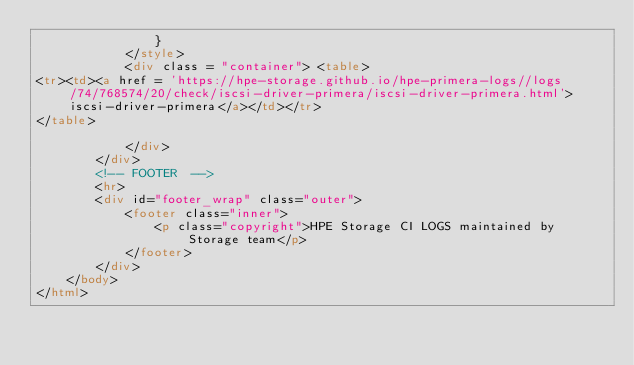<code> <loc_0><loc_0><loc_500><loc_500><_HTML_>                }
            </style>
            <div class = "container"> <table>
<tr><td><a href = 'https://hpe-storage.github.io/hpe-primera-logs//logs/74/768574/20/check/iscsi-driver-primera/iscsi-driver-primera.html'>iscsi-driver-primera</a></td></tr>
</table>

            </div>
        </div>
        <!-- FOOTER  -->
        <hr>
        <div id="footer_wrap" class="outer">
            <footer class="inner">
                <p class="copyright">HPE Storage CI LOGS maintained by Storage team</p>
            </footer>
        </div>
    </body>
</html>
</code> 